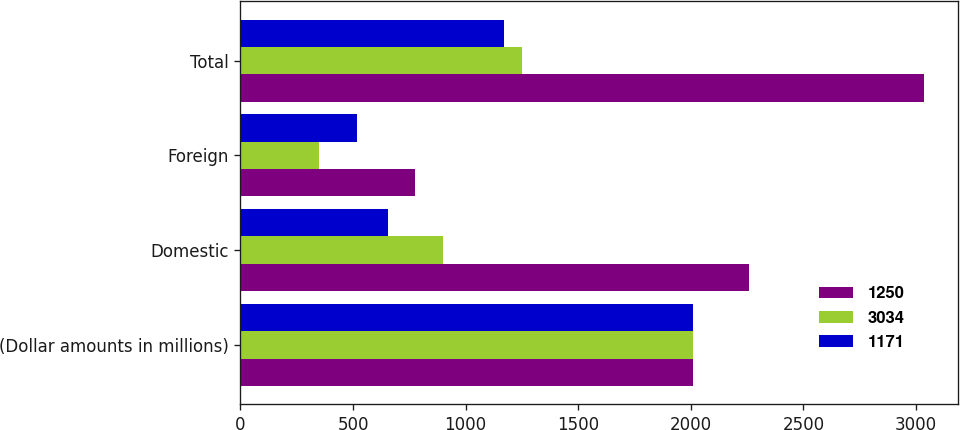<chart> <loc_0><loc_0><loc_500><loc_500><stacked_bar_chart><ecel><fcel>(Dollar amounts in millions)<fcel>Domestic<fcel>Foreign<fcel>Total<nl><fcel>1250<fcel>2010<fcel>2258<fcel>776<fcel>3034<nl><fcel>3034<fcel>2009<fcel>899<fcel>351<fcel>1250<nl><fcel>1171<fcel>2008<fcel>654<fcel>517<fcel>1171<nl></chart> 